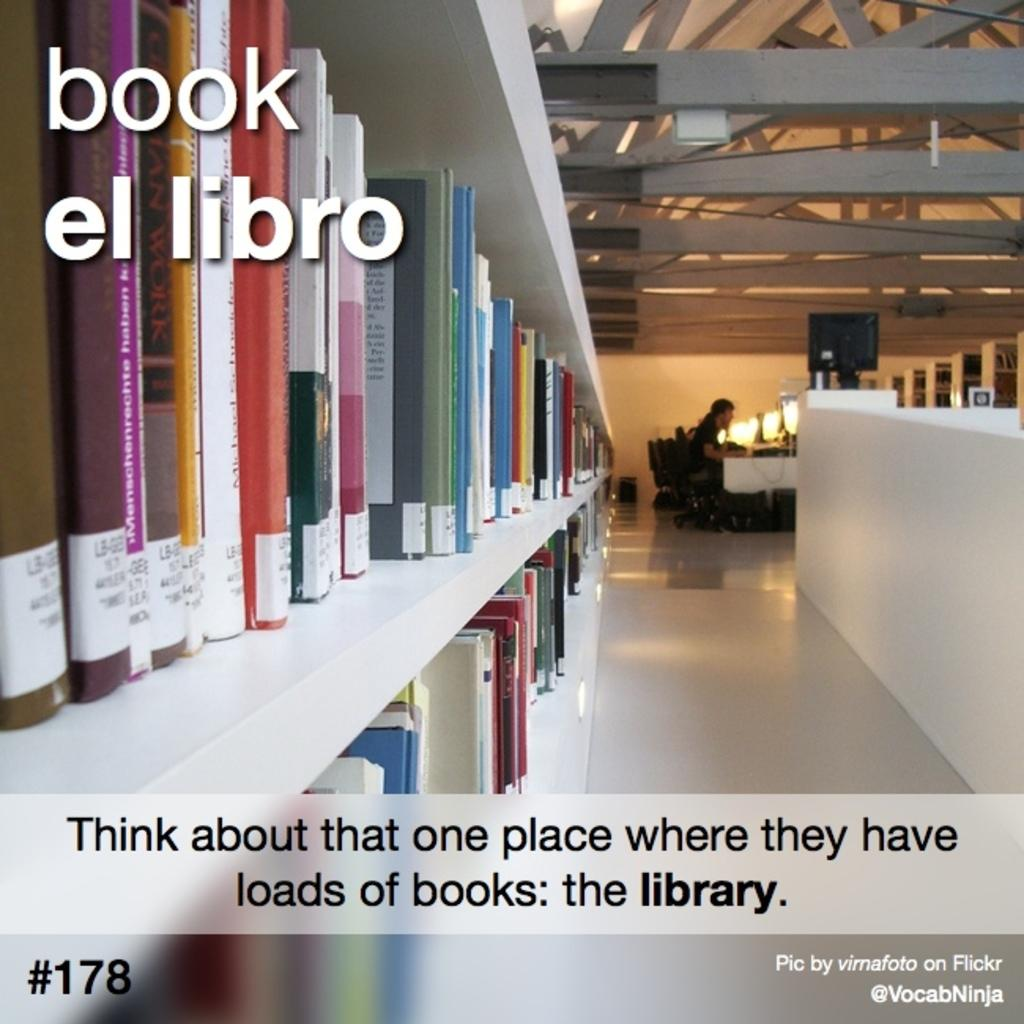Provide a one-sentence caption for the provided image. An advertisement for the library shows someone studying peacefully and a large selection of books. 